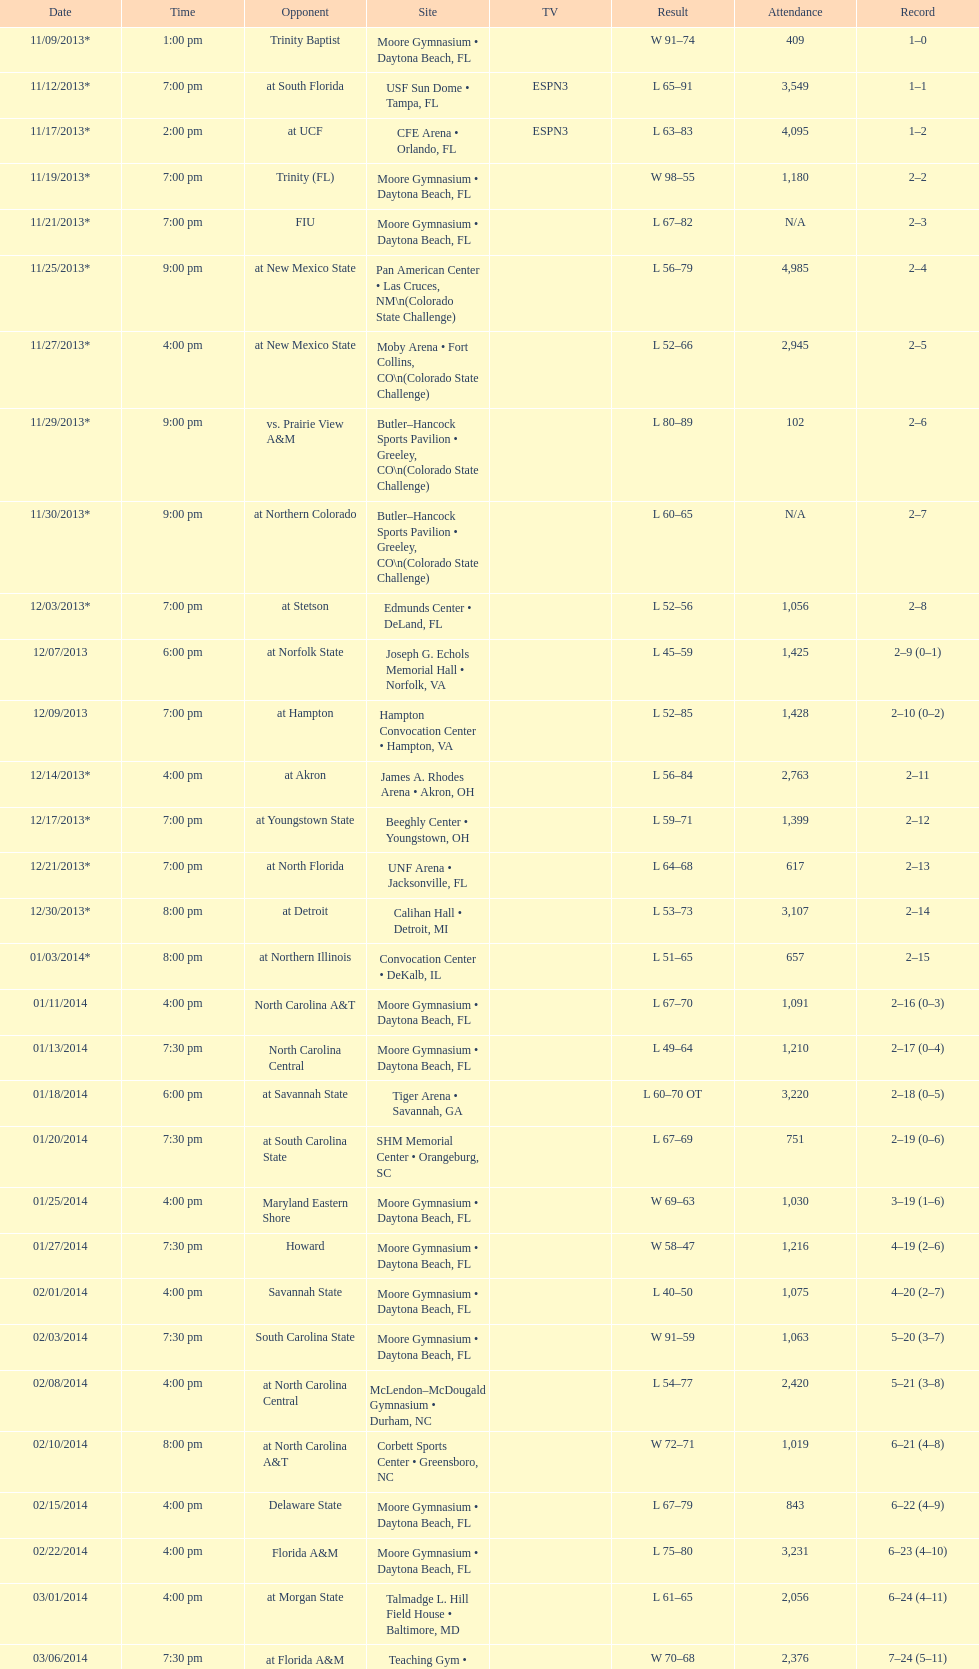How many teams had at most an attendance of 1,000? 6. 